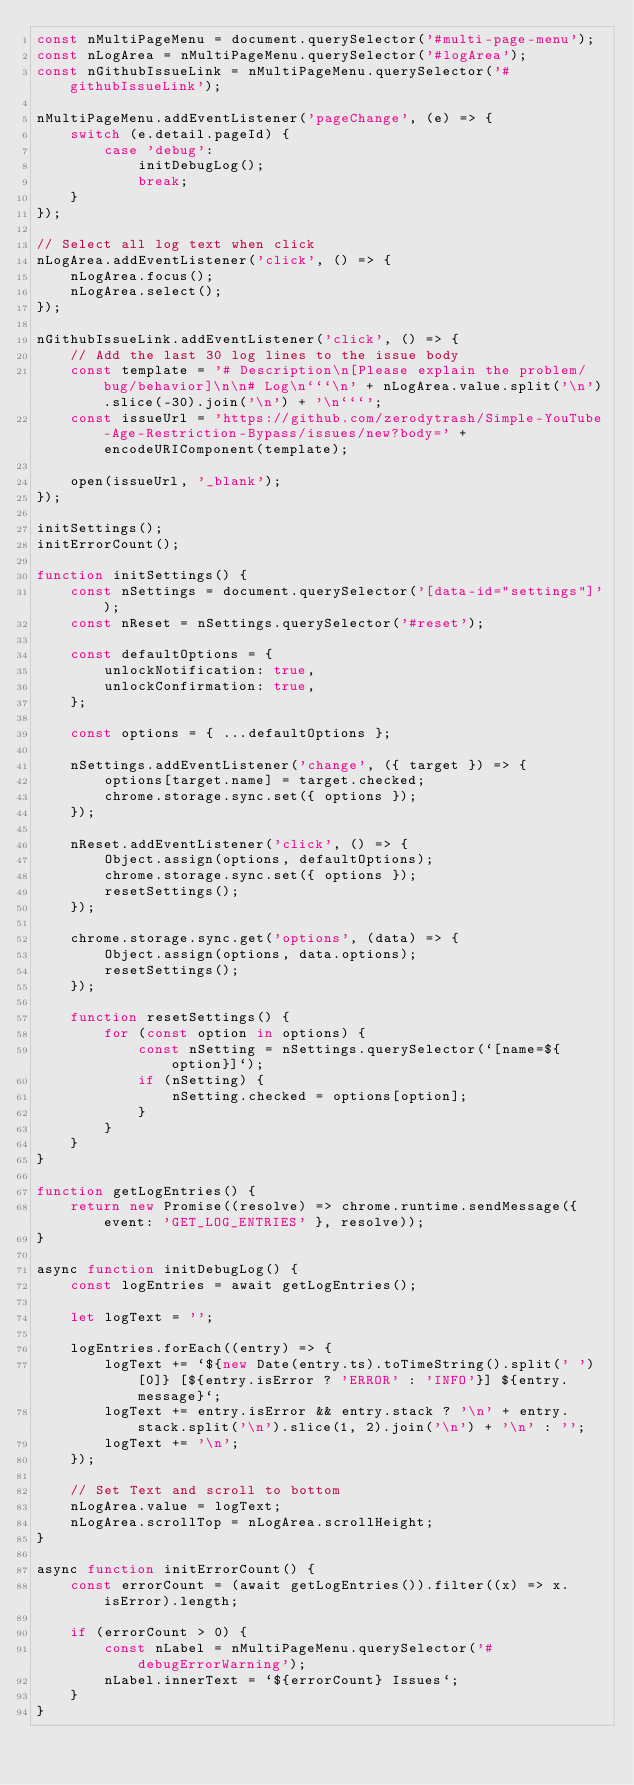<code> <loc_0><loc_0><loc_500><loc_500><_JavaScript_>const nMultiPageMenu = document.querySelector('#multi-page-menu');
const nLogArea = nMultiPageMenu.querySelector('#logArea');
const nGithubIssueLink = nMultiPageMenu.querySelector('#githubIssueLink');

nMultiPageMenu.addEventListener('pageChange', (e) => {
    switch (e.detail.pageId) {
        case 'debug':
            initDebugLog();
            break;
    }
});

// Select all log text when click
nLogArea.addEventListener('click', () => {
    nLogArea.focus();
    nLogArea.select();
});

nGithubIssueLink.addEventListener('click', () => {
    // Add the last 30 log lines to the issue body
    const template = '# Description\n[Please explain the problem/bug/behavior]\n\n# Log\n```\n' + nLogArea.value.split('\n').slice(-30).join('\n') + '\n```';
    const issueUrl = 'https://github.com/zerodytrash/Simple-YouTube-Age-Restriction-Bypass/issues/new?body=' + encodeURIComponent(template);

    open(issueUrl, '_blank');
});

initSettings();
initErrorCount();

function initSettings() {
    const nSettings = document.querySelector('[data-id="settings"]');
    const nReset = nSettings.querySelector('#reset');

    const defaultOptions = {
        unlockNotification: true,
        unlockConfirmation: true,
    };

    const options = { ...defaultOptions };

    nSettings.addEventListener('change', ({ target }) => {
        options[target.name] = target.checked;
        chrome.storage.sync.set({ options });
    });

    nReset.addEventListener('click', () => {
        Object.assign(options, defaultOptions);
        chrome.storage.sync.set({ options });
        resetSettings();
    });

    chrome.storage.sync.get('options', (data) => {
        Object.assign(options, data.options);
        resetSettings();
    });

    function resetSettings() {
        for (const option in options) {
            const nSetting = nSettings.querySelector(`[name=${option}]`);
            if (nSetting) {
                nSetting.checked = options[option];
            }
        }
    }
}

function getLogEntries() {
    return new Promise((resolve) => chrome.runtime.sendMessage({ event: 'GET_LOG_ENTRIES' }, resolve));
}

async function initDebugLog() {
    const logEntries = await getLogEntries();

    let logText = '';

    logEntries.forEach((entry) => {
        logText += `${new Date(entry.ts).toTimeString().split(' ')[0]} [${entry.isError ? 'ERROR' : 'INFO'}] ${entry.message}`;
        logText += entry.isError && entry.stack ? '\n' + entry.stack.split('\n').slice(1, 2).join('\n') + '\n' : '';
        logText += '\n';
    });

    // Set Text and scroll to bottom
    nLogArea.value = logText;
    nLogArea.scrollTop = nLogArea.scrollHeight;
}

async function initErrorCount() {
    const errorCount = (await getLogEntries()).filter((x) => x.isError).length;

    if (errorCount > 0) {
        const nLabel = nMultiPageMenu.querySelector('#debugErrorWarning');
        nLabel.innerText = `${errorCount} Issues`;
    }
}
</code> 